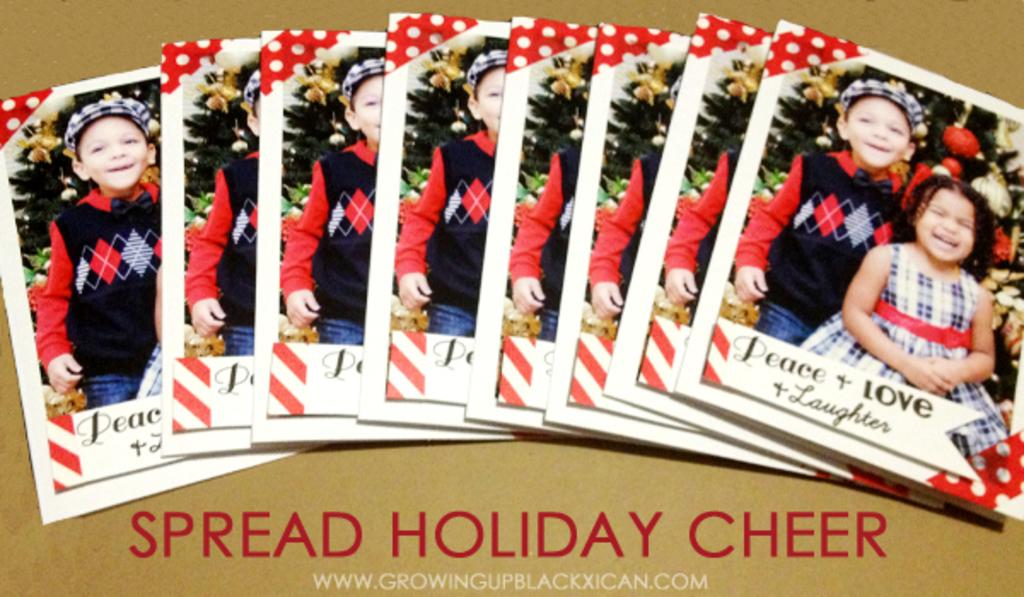What is present on the floor in the image? There are photocopies of a picture on the floor. What can be seen at the bottom of the image? There is text visible at the bottom of the image. What time of day does the image appear to have been taken? The image appears to have been taken during the day. What type of hat is the yak wearing in the image? There is no yak or hat present in the image. 